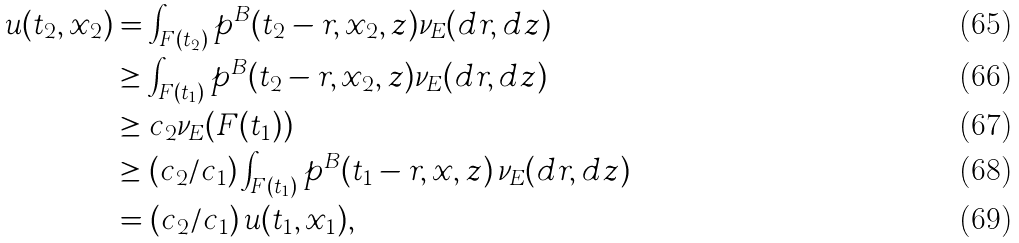<formula> <loc_0><loc_0><loc_500><loc_500>u ( t _ { 2 } , x _ { 2 } ) & = \int _ { F ( t _ { 2 } ) } p ^ { B } ( t _ { 2 } - r , x _ { 2 } , z ) \nu _ { E } ( d r , d z ) \\ & \geq \int _ { F ( t _ { 1 } ) } p ^ { B } ( t _ { 2 } - r , x _ { 2 } , z ) \nu _ { E } ( d r , d z ) \\ & \geq c _ { 2 } \nu _ { E } ( F ( t _ { 1 } ) ) \\ & \geq ( c _ { 2 } / c _ { 1 } ) \int _ { F ( t _ { 1 } ) } p ^ { B } ( t _ { 1 } - r , x , z ) \, \nu _ { E } ( d r , d z ) \\ & = ( c _ { 2 } / c _ { 1 } ) \, u ( t _ { 1 } , x _ { 1 } ) ,</formula> 